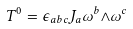<formula> <loc_0><loc_0><loc_500><loc_500>T ^ { 0 } = { \epsilon } _ { a b c } J _ { a } { \omega } ^ { b } { \wedge } { \omega } ^ { c }</formula> 